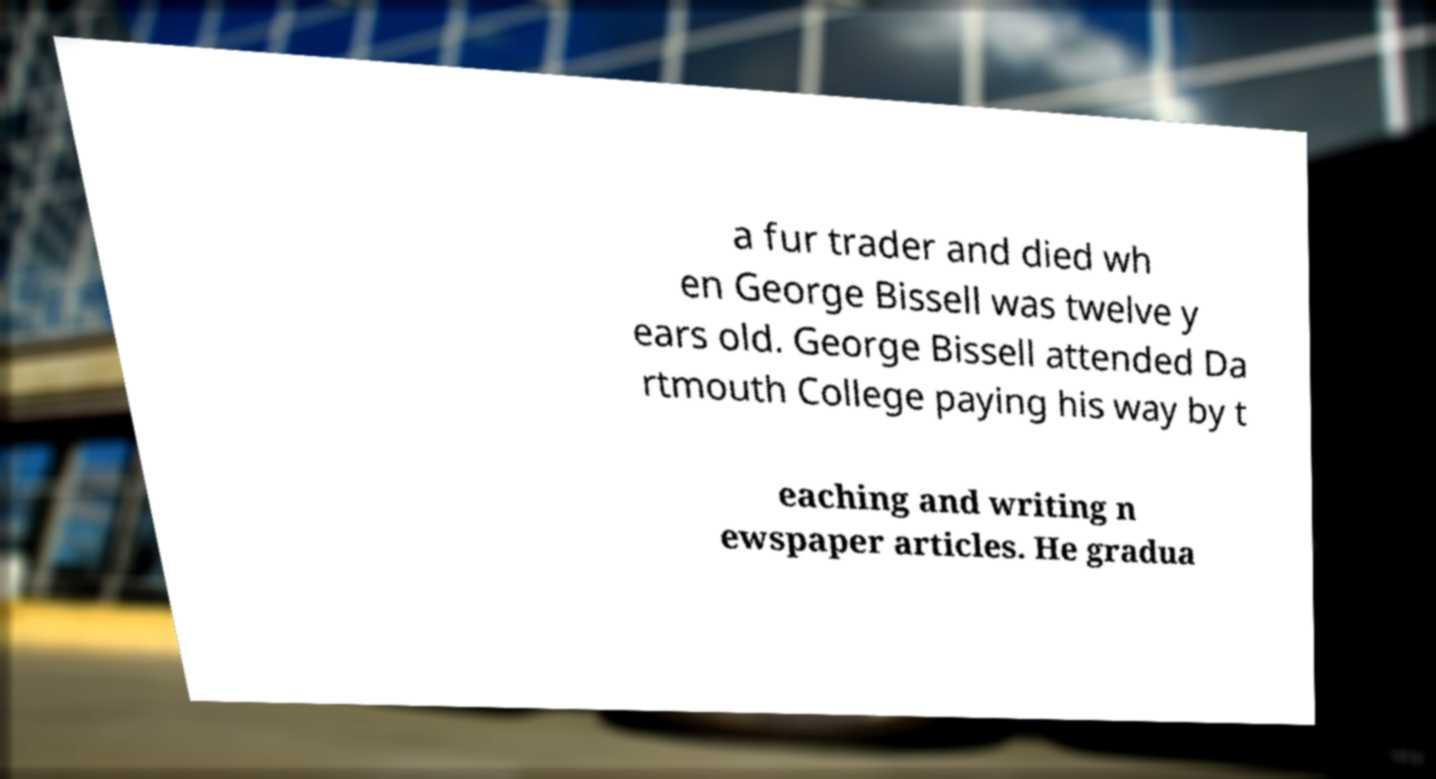There's text embedded in this image that I need extracted. Can you transcribe it verbatim? a fur trader and died wh en George Bissell was twelve y ears old. George Bissell attended Da rtmouth College paying his way by t eaching and writing n ewspaper articles. He gradua 